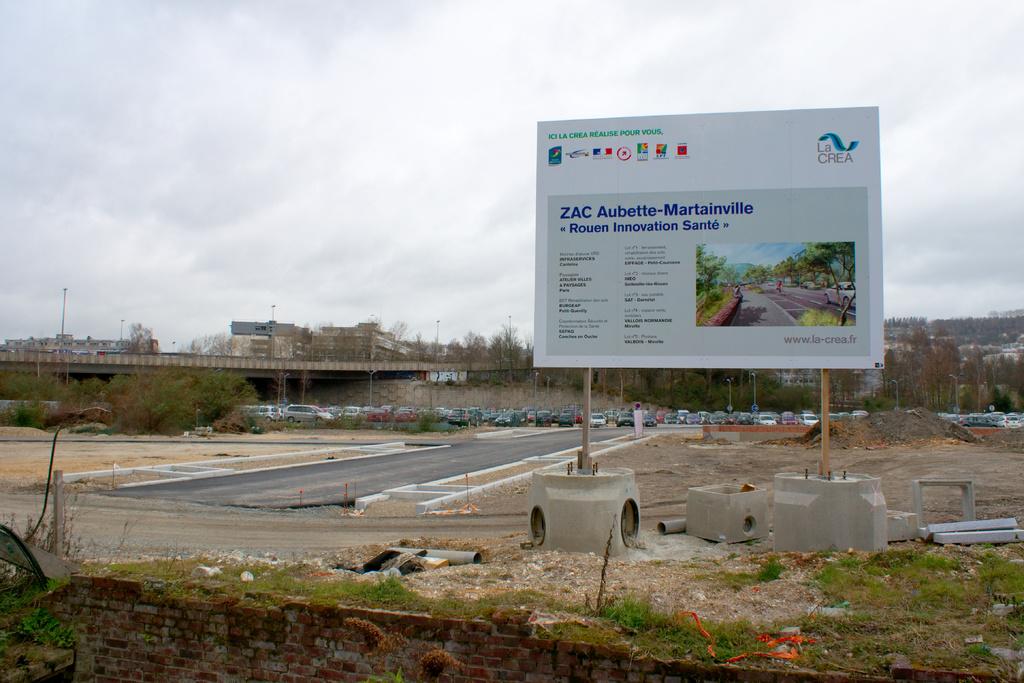Is this the la crea company?
Your answer should be compact. Yes. 